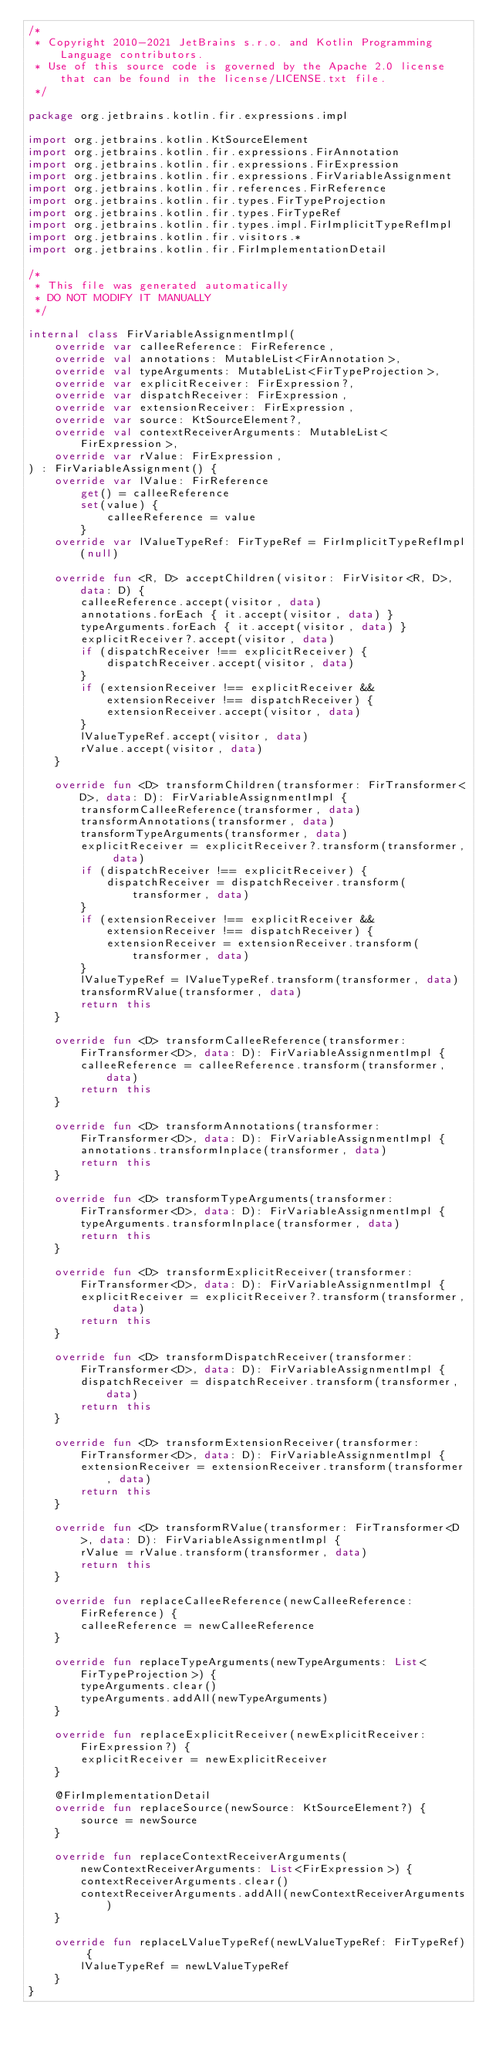<code> <loc_0><loc_0><loc_500><loc_500><_Kotlin_>/*
 * Copyright 2010-2021 JetBrains s.r.o. and Kotlin Programming Language contributors.
 * Use of this source code is governed by the Apache 2.0 license that can be found in the license/LICENSE.txt file.
 */

package org.jetbrains.kotlin.fir.expressions.impl

import org.jetbrains.kotlin.KtSourceElement
import org.jetbrains.kotlin.fir.expressions.FirAnnotation
import org.jetbrains.kotlin.fir.expressions.FirExpression
import org.jetbrains.kotlin.fir.expressions.FirVariableAssignment
import org.jetbrains.kotlin.fir.references.FirReference
import org.jetbrains.kotlin.fir.types.FirTypeProjection
import org.jetbrains.kotlin.fir.types.FirTypeRef
import org.jetbrains.kotlin.fir.types.impl.FirImplicitTypeRefImpl
import org.jetbrains.kotlin.fir.visitors.*
import org.jetbrains.kotlin.fir.FirImplementationDetail

/*
 * This file was generated automatically
 * DO NOT MODIFY IT MANUALLY
 */

internal class FirVariableAssignmentImpl(
    override var calleeReference: FirReference,
    override val annotations: MutableList<FirAnnotation>,
    override val typeArguments: MutableList<FirTypeProjection>,
    override var explicitReceiver: FirExpression?,
    override var dispatchReceiver: FirExpression,
    override var extensionReceiver: FirExpression,
    override var source: KtSourceElement?,
    override val contextReceiverArguments: MutableList<FirExpression>,
    override var rValue: FirExpression,
) : FirVariableAssignment() {
    override var lValue: FirReference 
        get() = calleeReference
        set(value) {
            calleeReference = value
        }
    override var lValueTypeRef: FirTypeRef = FirImplicitTypeRefImpl(null)

    override fun <R, D> acceptChildren(visitor: FirVisitor<R, D>, data: D) {
        calleeReference.accept(visitor, data)
        annotations.forEach { it.accept(visitor, data) }
        typeArguments.forEach { it.accept(visitor, data) }
        explicitReceiver?.accept(visitor, data)
        if (dispatchReceiver !== explicitReceiver) {
            dispatchReceiver.accept(visitor, data)
        }
        if (extensionReceiver !== explicitReceiver && extensionReceiver !== dispatchReceiver) {
            extensionReceiver.accept(visitor, data)
        }
        lValueTypeRef.accept(visitor, data)
        rValue.accept(visitor, data)
    }

    override fun <D> transformChildren(transformer: FirTransformer<D>, data: D): FirVariableAssignmentImpl {
        transformCalleeReference(transformer, data)
        transformAnnotations(transformer, data)
        transformTypeArguments(transformer, data)
        explicitReceiver = explicitReceiver?.transform(transformer, data)
        if (dispatchReceiver !== explicitReceiver) {
            dispatchReceiver = dispatchReceiver.transform(transformer, data)
        }
        if (extensionReceiver !== explicitReceiver && extensionReceiver !== dispatchReceiver) {
            extensionReceiver = extensionReceiver.transform(transformer, data)
        }
        lValueTypeRef = lValueTypeRef.transform(transformer, data)
        transformRValue(transformer, data)
        return this
    }

    override fun <D> transformCalleeReference(transformer: FirTransformer<D>, data: D): FirVariableAssignmentImpl {
        calleeReference = calleeReference.transform(transformer, data)
        return this
    }

    override fun <D> transformAnnotations(transformer: FirTransformer<D>, data: D): FirVariableAssignmentImpl {
        annotations.transformInplace(transformer, data)
        return this
    }

    override fun <D> transformTypeArguments(transformer: FirTransformer<D>, data: D): FirVariableAssignmentImpl {
        typeArguments.transformInplace(transformer, data)
        return this
    }

    override fun <D> transformExplicitReceiver(transformer: FirTransformer<D>, data: D): FirVariableAssignmentImpl {
        explicitReceiver = explicitReceiver?.transform(transformer, data)
        return this
    }

    override fun <D> transformDispatchReceiver(transformer: FirTransformer<D>, data: D): FirVariableAssignmentImpl {
        dispatchReceiver = dispatchReceiver.transform(transformer, data)
        return this
    }

    override fun <D> transformExtensionReceiver(transformer: FirTransformer<D>, data: D): FirVariableAssignmentImpl {
        extensionReceiver = extensionReceiver.transform(transformer, data)
        return this
    }

    override fun <D> transformRValue(transformer: FirTransformer<D>, data: D): FirVariableAssignmentImpl {
        rValue = rValue.transform(transformer, data)
        return this
    }

    override fun replaceCalleeReference(newCalleeReference: FirReference) {
        calleeReference = newCalleeReference
    }

    override fun replaceTypeArguments(newTypeArguments: List<FirTypeProjection>) {
        typeArguments.clear()
        typeArguments.addAll(newTypeArguments)
    }

    override fun replaceExplicitReceiver(newExplicitReceiver: FirExpression?) {
        explicitReceiver = newExplicitReceiver
    }

    @FirImplementationDetail
    override fun replaceSource(newSource: KtSourceElement?) {
        source = newSource
    }

    override fun replaceContextReceiverArguments(newContextReceiverArguments: List<FirExpression>) {
        contextReceiverArguments.clear()
        contextReceiverArguments.addAll(newContextReceiverArguments)
    }

    override fun replaceLValueTypeRef(newLValueTypeRef: FirTypeRef) {
        lValueTypeRef = newLValueTypeRef
    }
}
</code> 